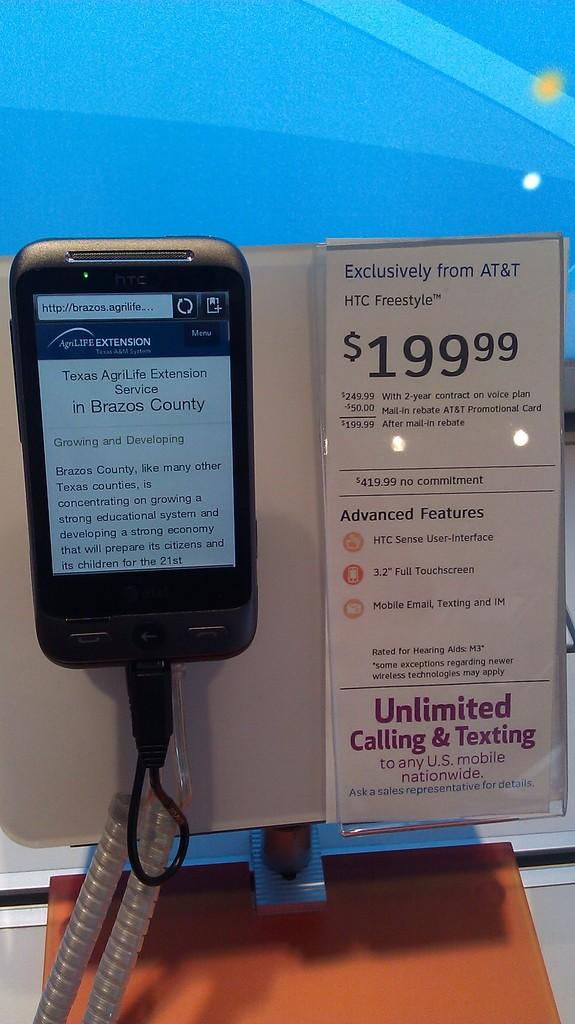What object is the main focus of the image? There is a mobile in the image. How is the mobile connected to a price tag? The mobile is attached to a price tag. What information is provided on the price tag? The price tag has text and numbers on it. What can be seen at the bottom of the image? There is a cable wire visible at the bottom of the image. What is the background color of the image? The background color of the image is blue. How many cows are visible in the image? There are no cows present in the image. What type of linen is used to cover the mobile in the image? There is no linen visible in the image, and the mobile is not covered. 